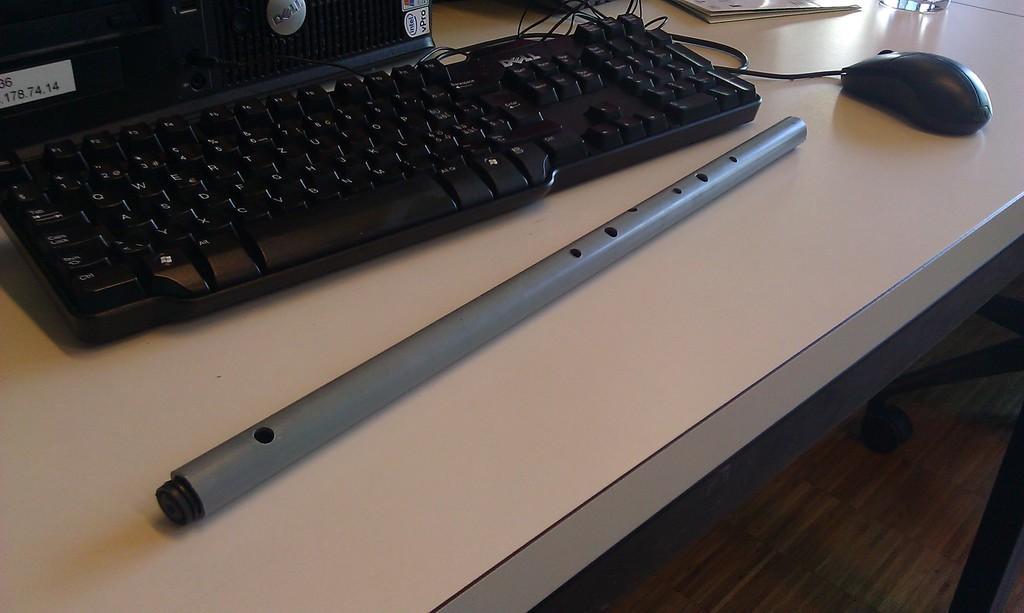Please provide a concise description of this image. In this image I can see the keyboard, mouse, flute, an electronic device and the papers. These are on the cream color surface. 